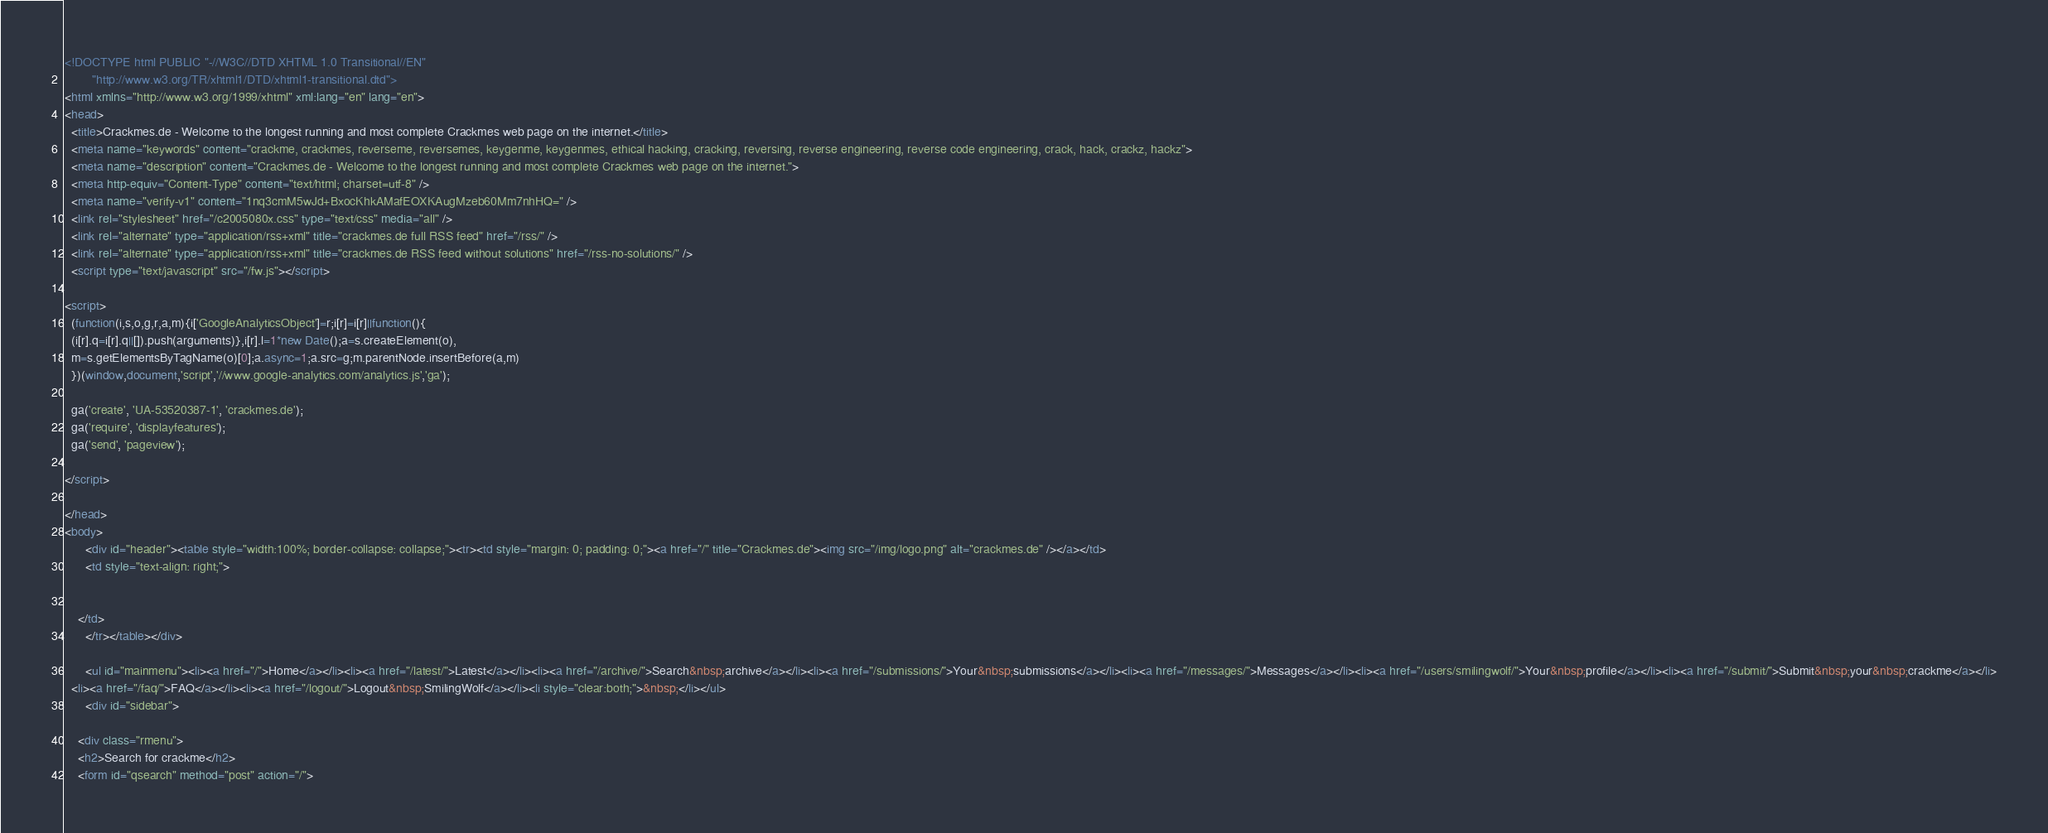Convert code to text. <code><loc_0><loc_0><loc_500><loc_500><_HTML_><!DOCTYPE html PUBLIC "-//W3C//DTD XHTML 1.0 Transitional//EN"
        "http://www.w3.org/TR/xhtml1/DTD/xhtml1-transitional.dtd">
<html xmlns="http://www.w3.org/1999/xhtml" xml:lang="en" lang="en">
<head>
  <title>Crackmes.de - Welcome to the longest running and most complete Crackmes web page on the internet.</title>
  <meta name="keywords" content="crackme, crackmes, reverseme, reversemes, keygenme, keygenmes, ethical hacking, cracking, reversing, reverse engineering, reverse code engineering, crack, hack, crackz, hackz">
  <meta name="description" content="Crackmes.de - Welcome to the longest running and most complete Crackmes web page on the internet.">
  <meta http-equiv="Content-Type" content="text/html; charset=utf-8" />
  <meta name="verify-v1" content="1nq3cmM5wJd+BxocKhkAMafEOXKAugMzeb60Mm7nhHQ=" />
  <link rel="stylesheet" href="/c2005080x.css" type="text/css" media="all" />
  <link rel="alternate" type="application/rss+xml" title="crackmes.de full RSS feed" href="/rss/" />
  <link rel="alternate" type="application/rss+xml" title="crackmes.de RSS feed without solutions" href="/rss-no-solutions/" />
  <script type="text/javascript" src="/fw.js"></script>

<script>
  (function(i,s,o,g,r,a,m){i['GoogleAnalyticsObject']=r;i[r]=i[r]||function(){
  (i[r].q=i[r].q||[]).push(arguments)},i[r].l=1*new Date();a=s.createElement(o),
  m=s.getElementsByTagName(o)[0];a.async=1;a.src=g;m.parentNode.insertBefore(a,m)
  })(window,document,'script','//www.google-analytics.com/analytics.js','ga');

  ga('create', 'UA-53520387-1', 'crackmes.de');
  ga('require', 'displayfeatures');
  ga('send', 'pageview');

</script>

</head>
<body>
      <div id="header"><table style="width:100%; border-collapse: collapse;"><tr><td style="margin: 0; padding: 0;"><a href="/" title="Crackmes.de"><img src="/img/logo.png" alt="crackmes.de" /></a></td>
      <td style="text-align: right;">


	</td>
      </tr></table></div>

      <ul id="mainmenu"><li><a href="/">Home</a></li><li><a href="/latest/">Latest</a></li><li><a href="/archive/">Search&nbsp;archive</a></li><li><a href="/submissions/">Your&nbsp;submissions</a></li><li><a href="/messages/">Messages</a></li><li><a href="/users/smilingwolf/">Your&nbsp;profile</a></li><li><a href="/submit/">Submit&nbsp;your&nbsp;crackme</a></li>
  <li><a href="/faq/">FAQ</a></li><li><a href="/logout/">Logout&nbsp;SmilingWolf</a></li><li style="clear:both;">&nbsp;</li></ul>
      <div id="sidebar">
      
    <div class="rmenu">
    <h2>Search for crackme</h2>
    <form id="qsearch" method="post" action="/"></code> 